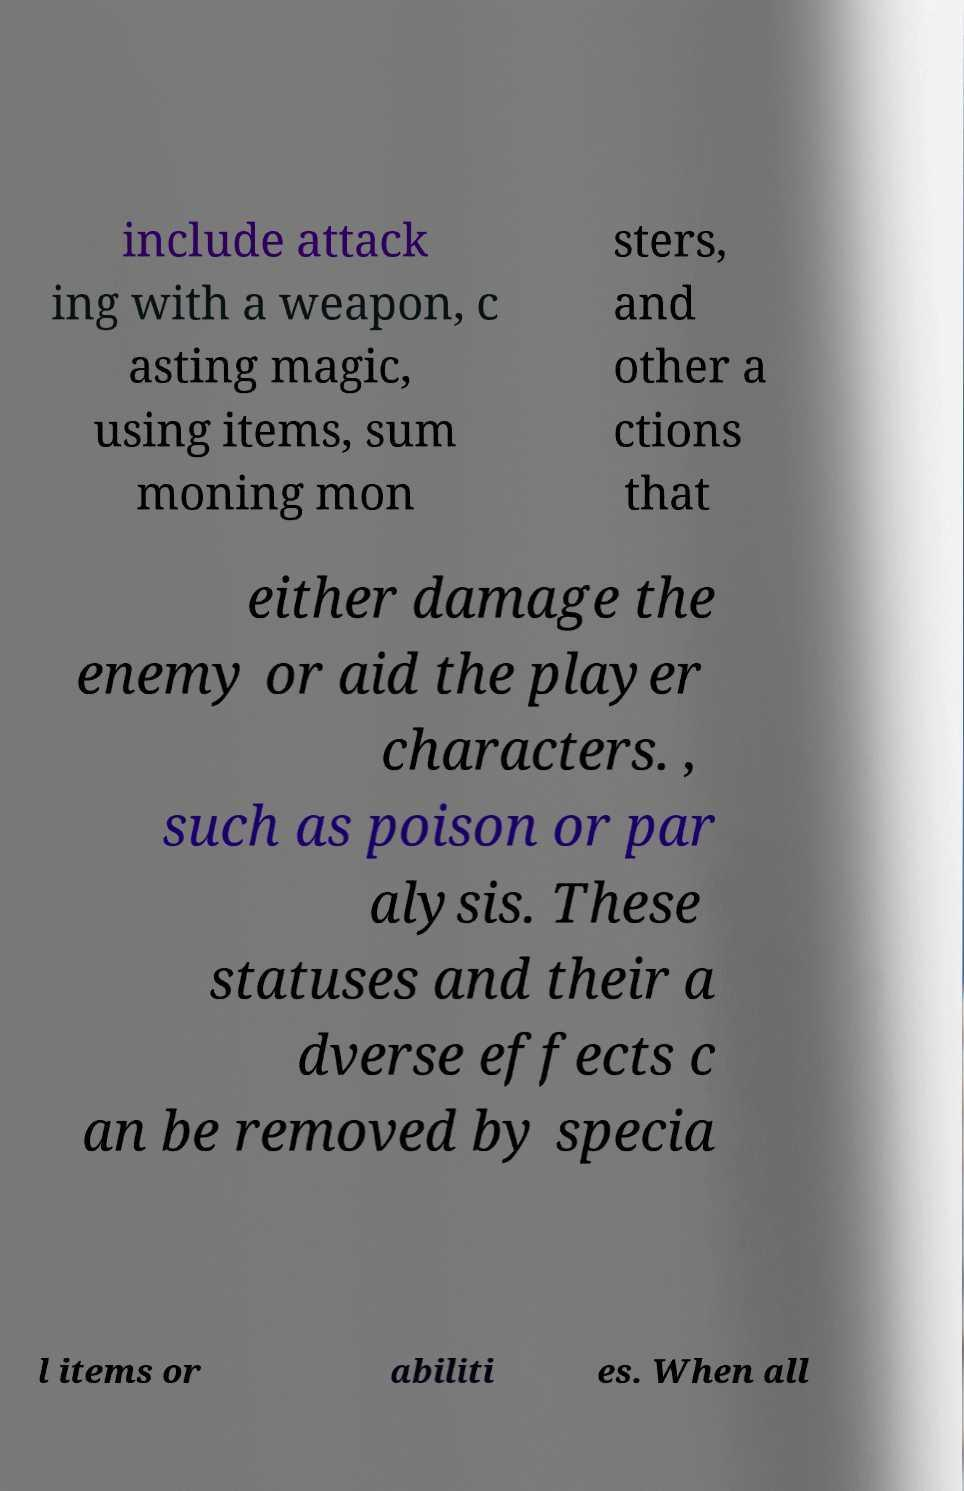Please read and relay the text visible in this image. What does it say? include attack ing with a weapon, c asting magic, using items, sum moning mon sters, and other a ctions that either damage the enemy or aid the player characters. , such as poison or par alysis. These statuses and their a dverse effects c an be removed by specia l items or abiliti es. When all 